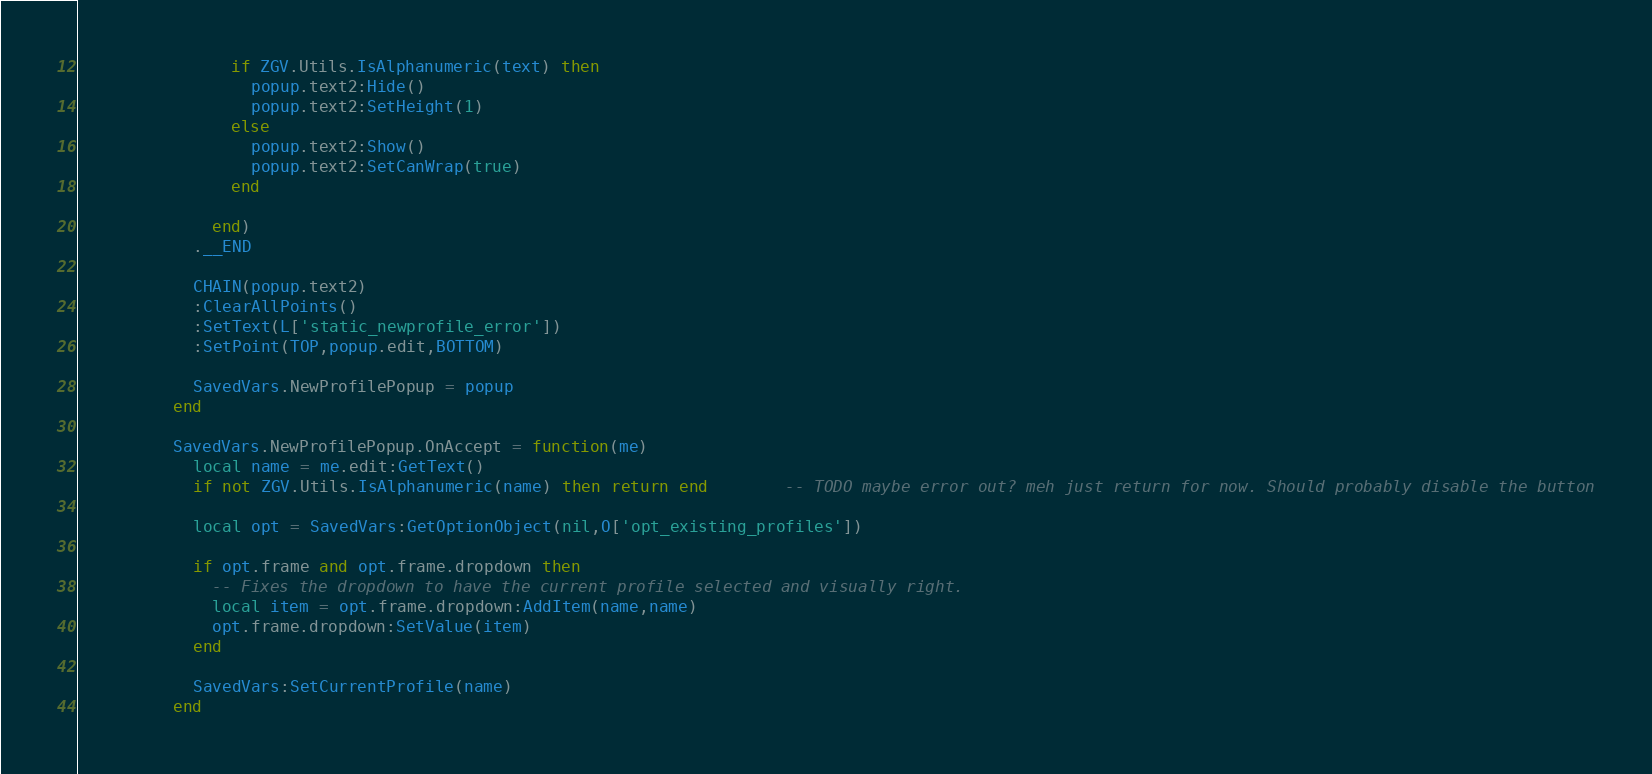<code> <loc_0><loc_0><loc_500><loc_500><_Lua_>
                if ZGV.Utils.IsAlphanumeric(text) then
                  popup.text2:Hide()
                  popup.text2:SetHeight(1)
                else
                  popup.text2:Show()
                  popup.text2:SetCanWrap(true)
                end

              end)
            .__END

            CHAIN(popup.text2)
            :ClearAllPoints()
            :SetText(L['static_newprofile_error'])
            :SetPoint(TOP,popup.edit,BOTTOM)

            SavedVars.NewProfilePopup = popup
          end

          SavedVars.NewProfilePopup.OnAccept = function(me)
            local name = me.edit:GetText()
            if not ZGV.Utils.IsAlphanumeric(name) then return end		-- TODO maybe error out? meh just return for now. Should probably disable the button

            local opt = SavedVars:GetOptionObject(nil,O['opt_existing_profiles'])

            if opt.frame and opt.frame.dropdown then
              -- Fixes the dropdown to have the current profile selected and visually right.
              local item = opt.frame.dropdown:AddItem(name,name)
              opt.frame.dropdown:SetValue(item)
            end

            SavedVars:SetCurrentProfile(name)
          end
</code> 